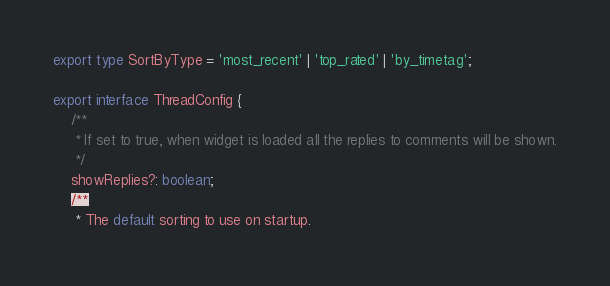<code> <loc_0><loc_0><loc_500><loc_500><_TypeScript_>export type SortByType = 'most_recent' | 'top_rated' | 'by_timetag';

export interface ThreadConfig {
    /**
     * If set to true, when widget is loaded all the replies to comments will be shown.
     */
    showReplies?: boolean;
    /**
     * The default sorting to use on startup.</code> 